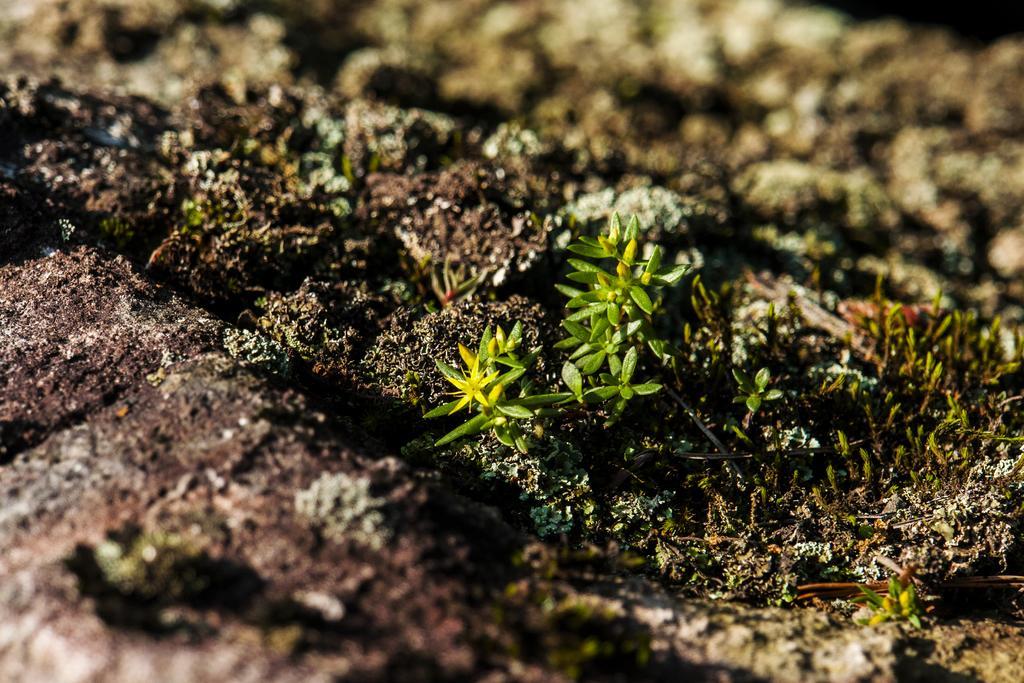Could you give a brief overview of what you see in this image? This image is taken outdoors. At the bottom of the image there is a ground and in the middle of the image there are a few little plants on the ground. 